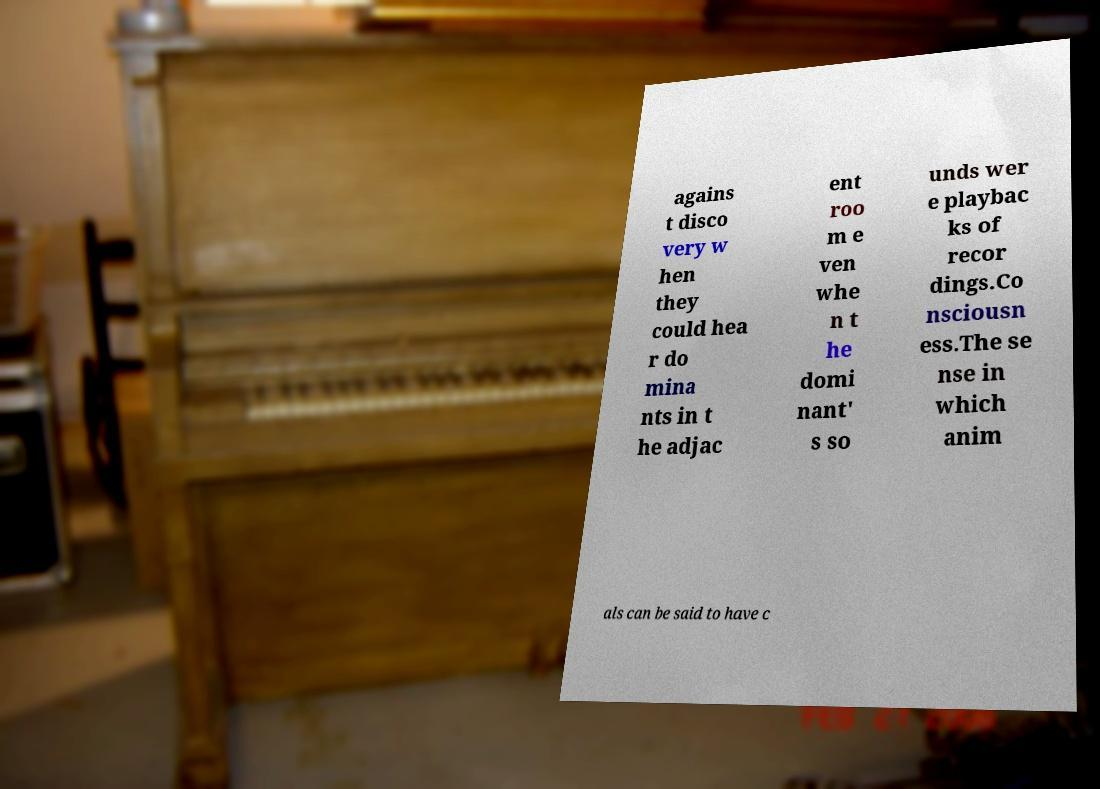What messages or text are displayed in this image? I need them in a readable, typed format. agains t disco very w hen they could hea r do mina nts in t he adjac ent roo m e ven whe n t he domi nant' s so unds wer e playbac ks of recor dings.Co nsciousn ess.The se nse in which anim als can be said to have c 